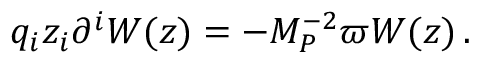<formula> <loc_0><loc_0><loc_500><loc_500>q _ { i } z _ { i } \partial ^ { i } W ( z ) = - M _ { P } ^ { - 2 } \varpi W ( z ) \, .</formula> 